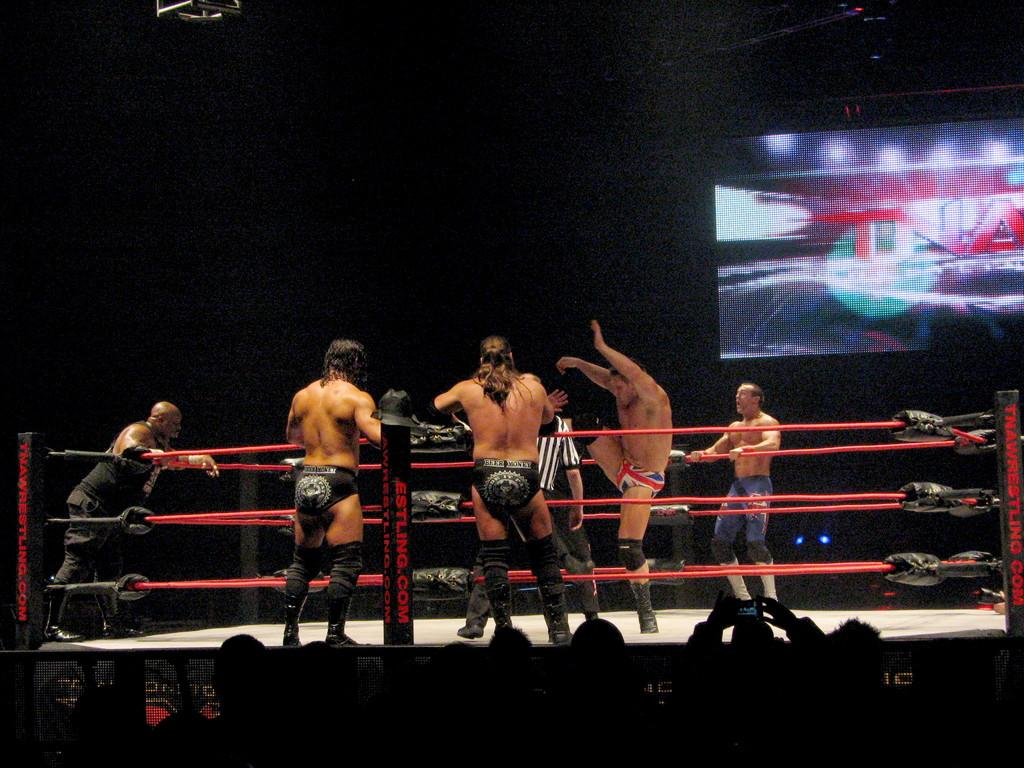Provide a one-sentence caption for the provided image. Wresters in the ring with men in black speedos watching from outside the ring, there is a large screen with TNA on it. 